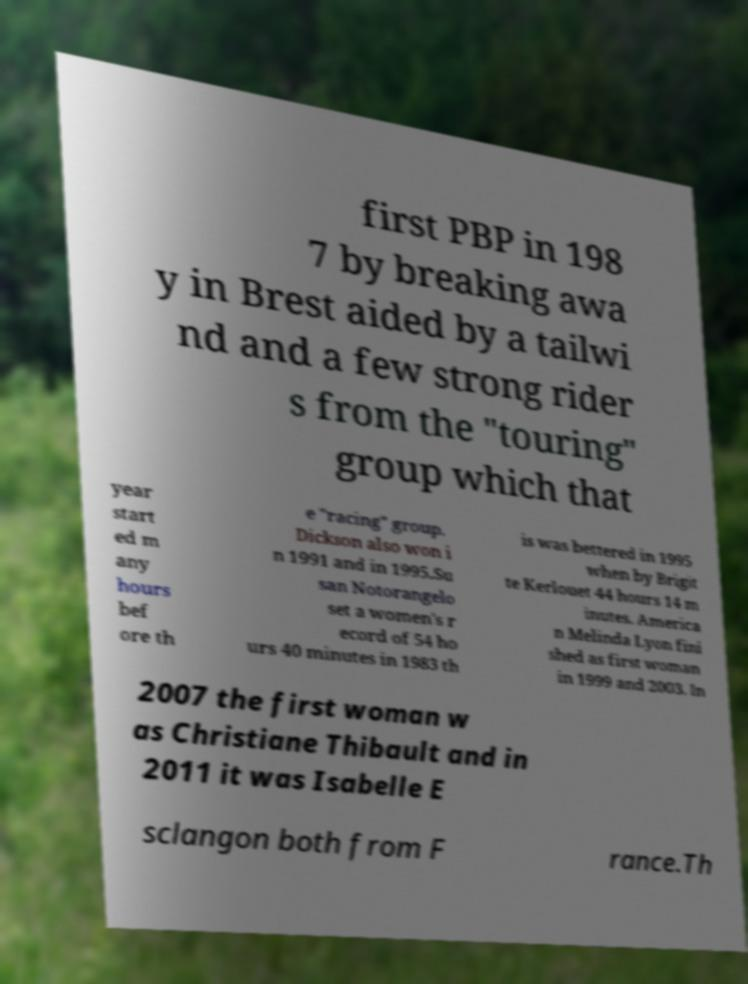For documentation purposes, I need the text within this image transcribed. Could you provide that? first PBP in 198 7 by breaking awa y in Brest aided by a tailwi nd and a few strong rider s from the "touring" group which that year start ed m any hours bef ore th e "racing" group. Dickson also won i n 1991 and in 1995.Su san Notorangelo set a women's r ecord of 54 ho urs 40 minutes in 1983 th is was bettered in 1995 when by Brigit te Kerlouet 44 hours 14 m inutes. America n Melinda Lyon fini shed as first woman in 1999 and 2003. In 2007 the first woman w as Christiane Thibault and in 2011 it was Isabelle E sclangon both from F rance.Th 